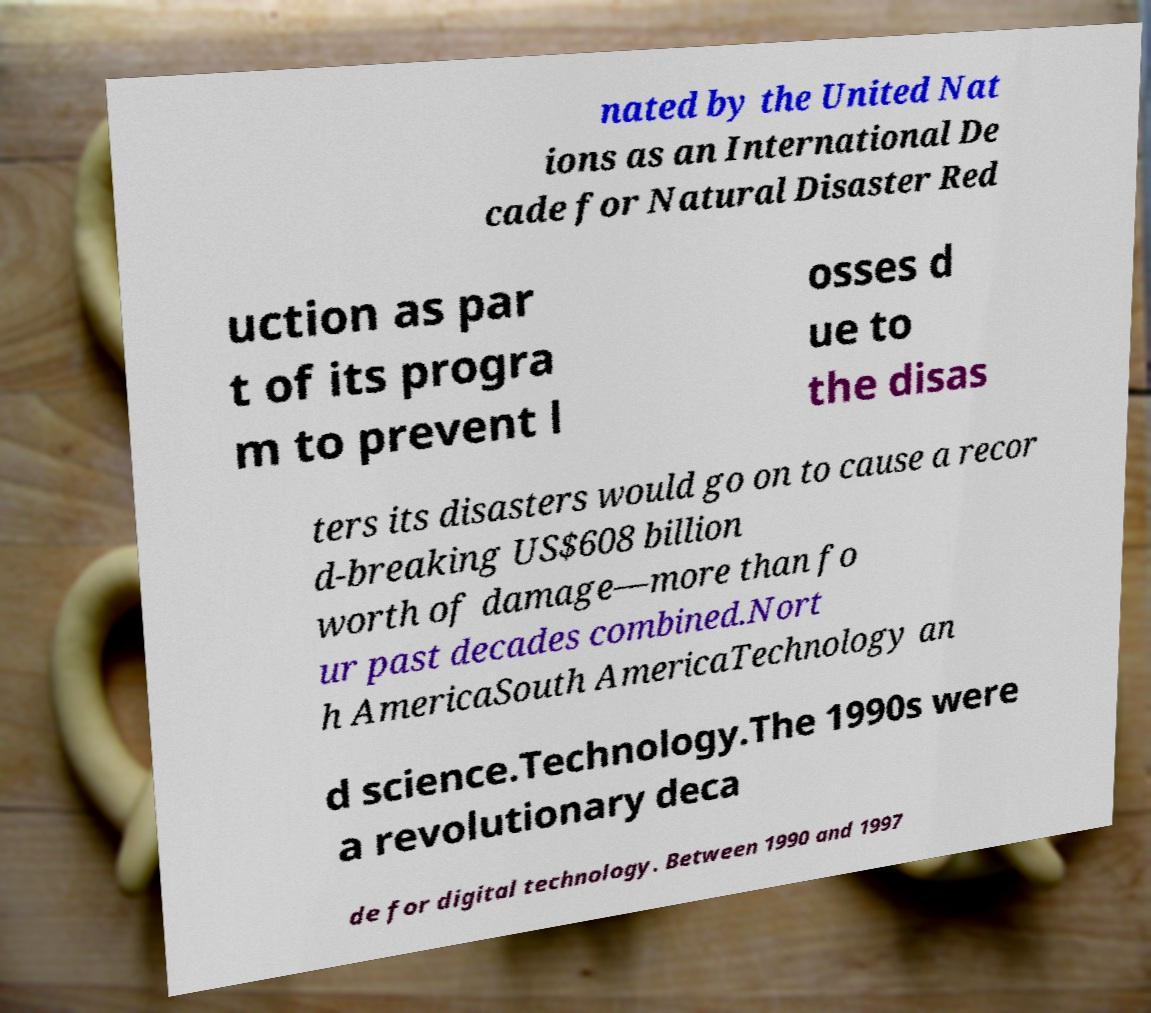I need the written content from this picture converted into text. Can you do that? nated by the United Nat ions as an International De cade for Natural Disaster Red uction as par t of its progra m to prevent l osses d ue to the disas ters its disasters would go on to cause a recor d-breaking US$608 billion worth of damage—more than fo ur past decades combined.Nort h AmericaSouth AmericaTechnology an d science.Technology.The 1990s were a revolutionary deca de for digital technology. Between 1990 and 1997 